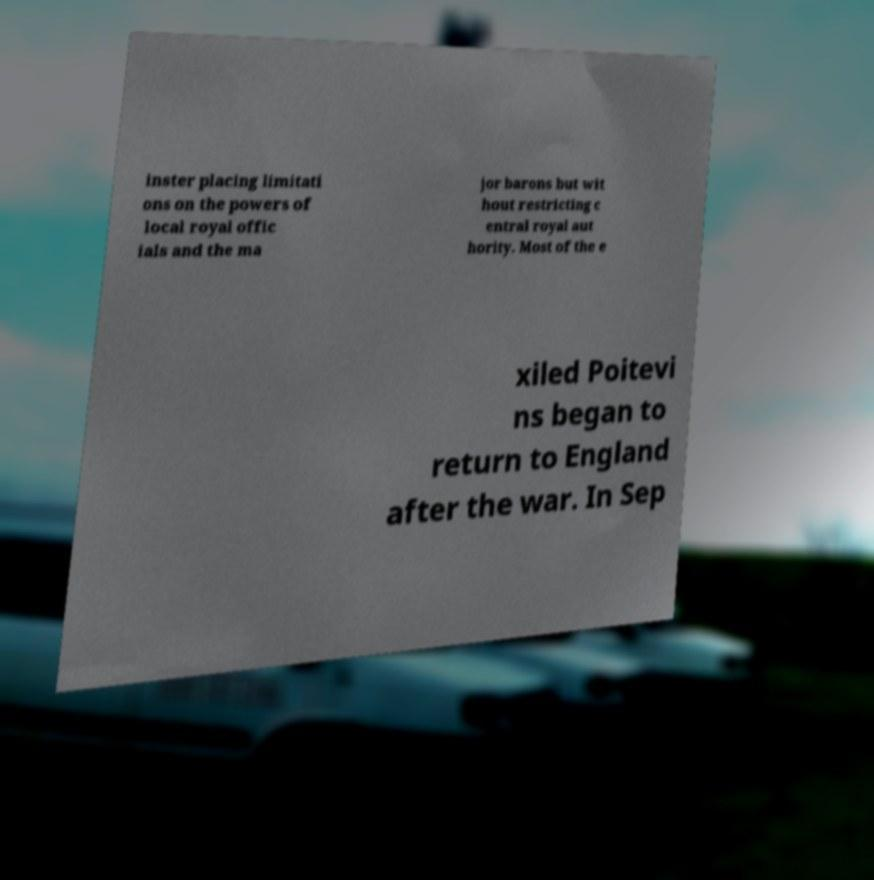Could you extract and type out the text from this image? inster placing limitati ons on the powers of local royal offic ials and the ma jor barons but wit hout restricting c entral royal aut hority. Most of the e xiled Poitevi ns began to return to England after the war. In Sep 